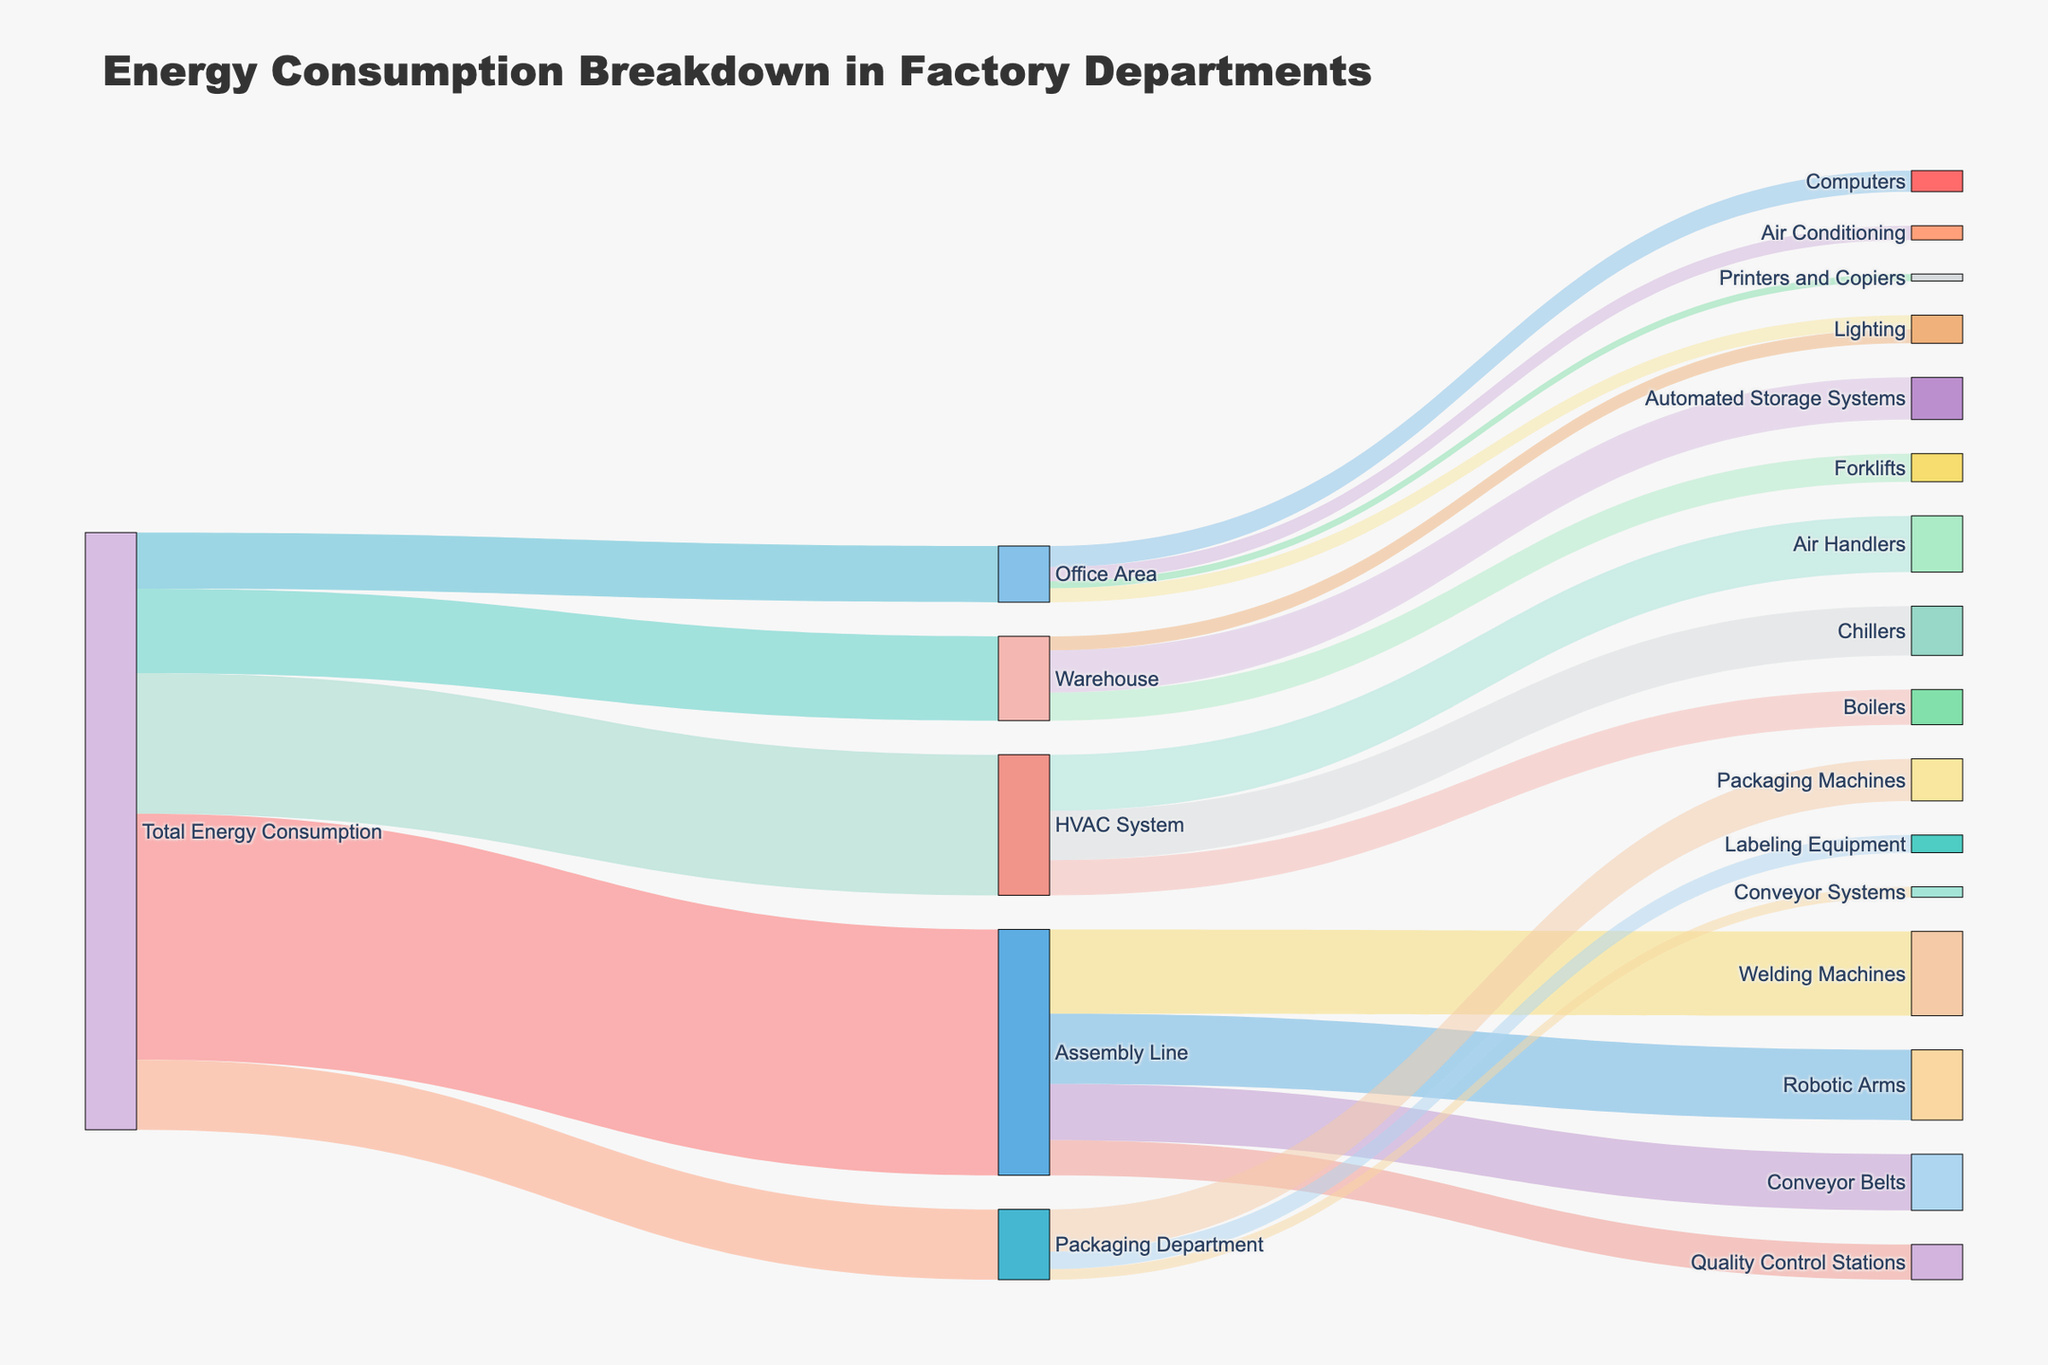What is the total energy consumption for the Assembly Line? The diagram shows a connection marker flowing from Total Energy Consumption to Assembly Line, with the value associated 3500 units.
Answer: 3500 units Which department has the lowest energy consumption? By comparing the values connected to each department from Total Energy Consumption, we see that Office Area has the lowest at 800 units.
Answer: Office Area What is the combined energy consumption for Warehouse and Office Area? Warehouse has 1200 units and Office Area has 800 units. Adding these up gives 1200 + 800 = 2000 units.
Answer: 2000 units How much energy is consumed by the Robotic Arms in the Assembly Line? Follow the flow from Assembly Line to Robotic Arms, which shows it consumes 1000 units of energy.
Answer: 1000 units What is the difference in energy consumption between the HVAC System and the Assembly Line? The HVAC System consumes 2000 units and the Assembly Line consumes 3500 units. The difference is 3500 - 2000 = 1500 units.
Answer: 1500 units Which equipment in the HVAC System consumes the most energy? By examining the links from HVAC System to its equipment, Air Handlers consume the most energy at 800 units.
Answer: Air Handlers How much energy is used by the Packaging Machines in the Packaging Department compared to the Labeling Equipment? Packaging Machines consume 600 units, while Labeling Equipment consumes 250 units. The difference is 600 - 250 = 350 units.
Answer: 350 units What is the total energy consumed by the different equipment types in the Office Area? Summing up the values connected to Office Area: Computers (300) + Lighting (200) + Printers and Copiers (100) + Air Conditioning (200) = 300 + 200 + 100 + 200 = 800 units.
Answer: 800 units Which department has the second highest energy consumption after the Assembly Line? Check the values of energy consumption per department. After Assembly Line (3500 units), the HVAC System has the second highest with 2000 units.
Answer: HVAC System What percentage of the total energy consumption is used by Forklifts in the Warehouse? Forklifts consume 400 units. The Total Energy Consumption is the sum of all departments: 3500 + 1200 + 800 + 1000 + 2000 = 8500 units. The percentage is (400 / 8500) * 100 ≈ 4.71%.
Answer: 4.71% 